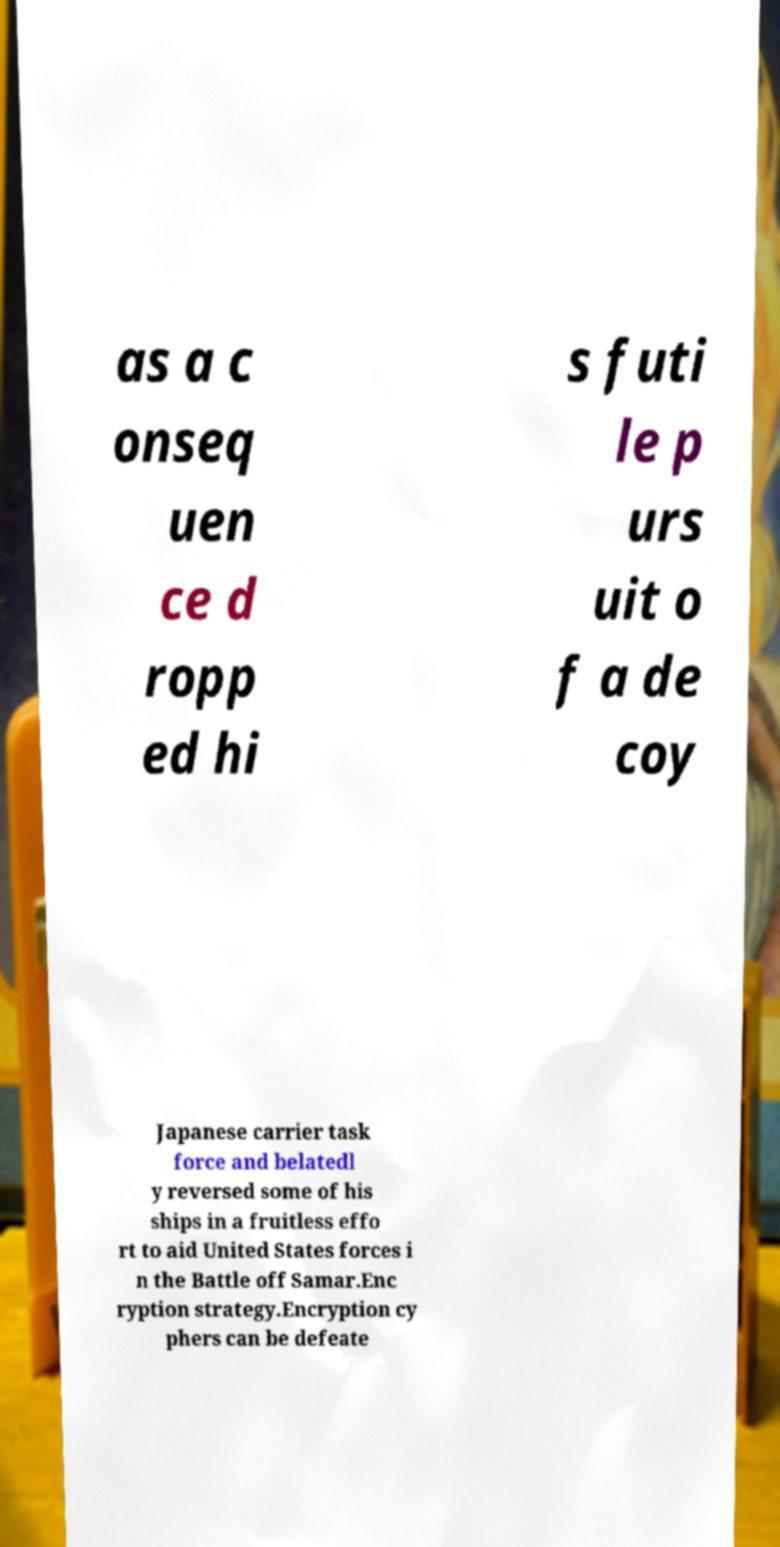Please identify and transcribe the text found in this image. as a c onseq uen ce d ropp ed hi s futi le p urs uit o f a de coy Japanese carrier task force and belatedl y reversed some of his ships in a fruitless effo rt to aid United States forces i n the Battle off Samar.Enc ryption strategy.Encryption cy phers can be defeate 